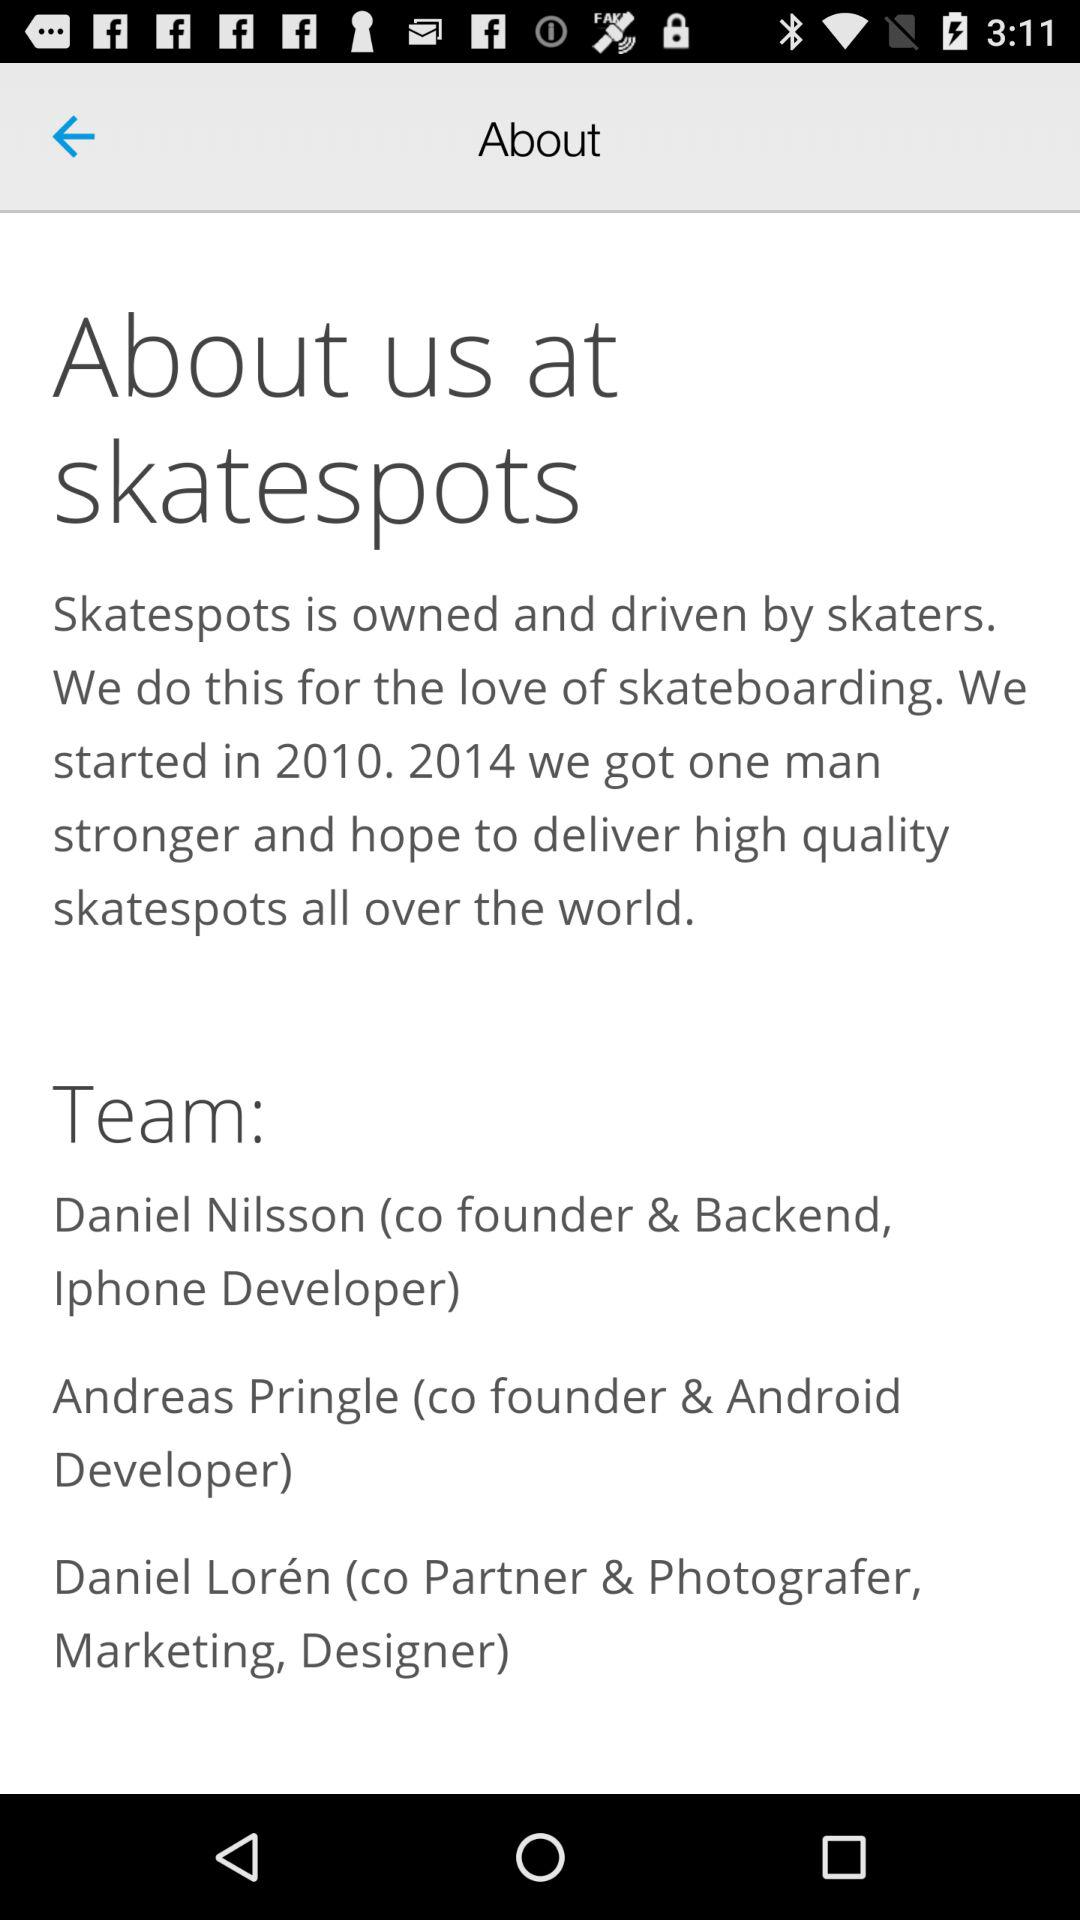How many members are there in the skatespots team?
Answer the question using a single word or phrase. 3 